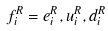<formula> <loc_0><loc_0><loc_500><loc_500>f ^ { R } _ { i } = e _ { i } ^ { R } , u _ { i } ^ { R } , d _ { i } ^ { R }</formula> 